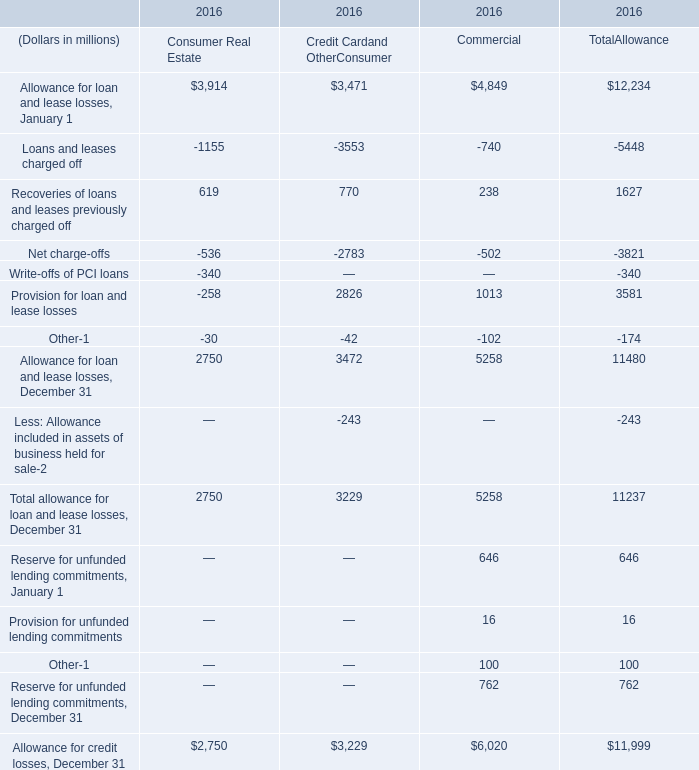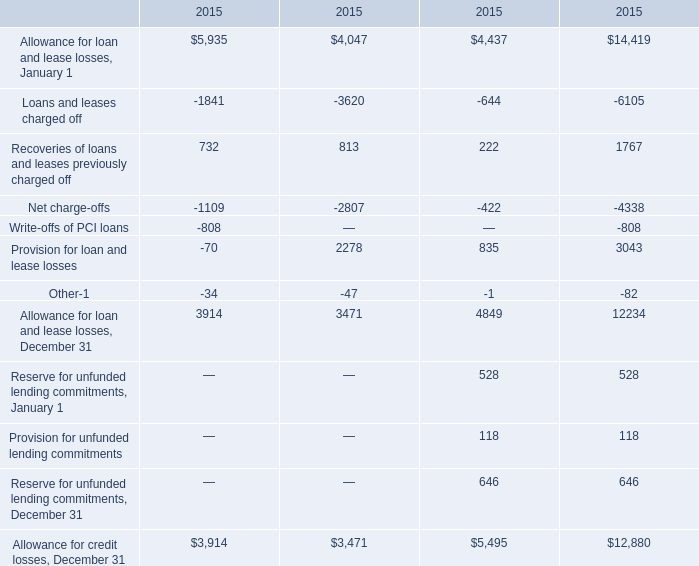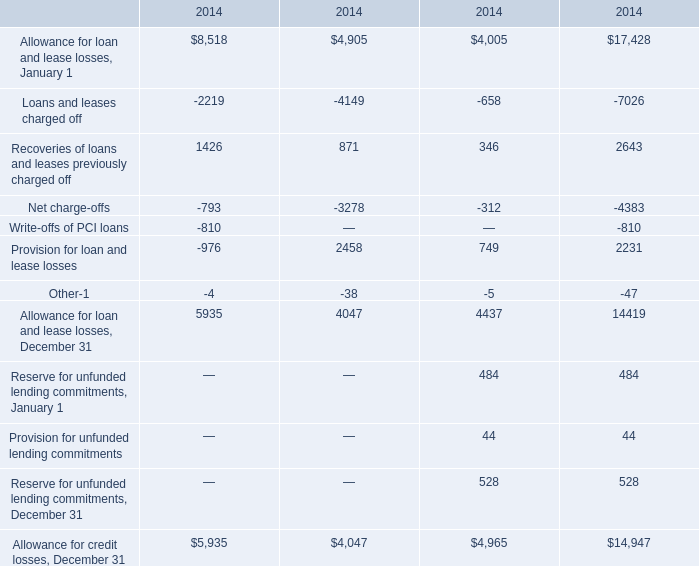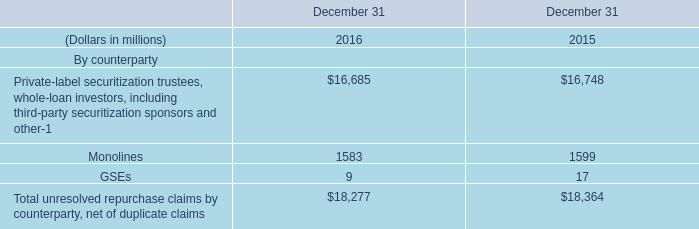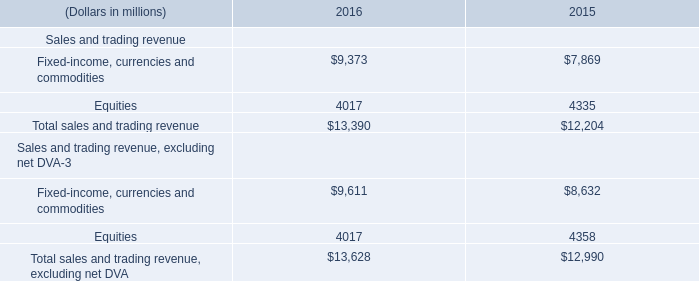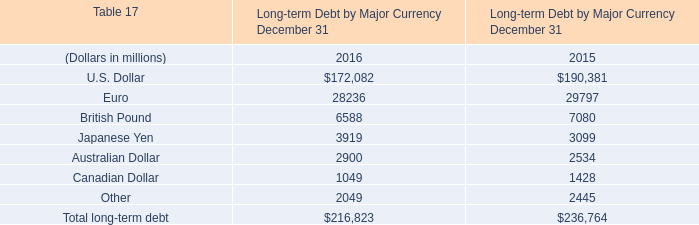What is the total amount of Allowance for credit losses, December 31 of 2015.3, and Allowance for loan and lease losses, January 1 of 2014.3 ? 
Computations: (12880.0 + 17428.0)
Answer: 30308.0. 